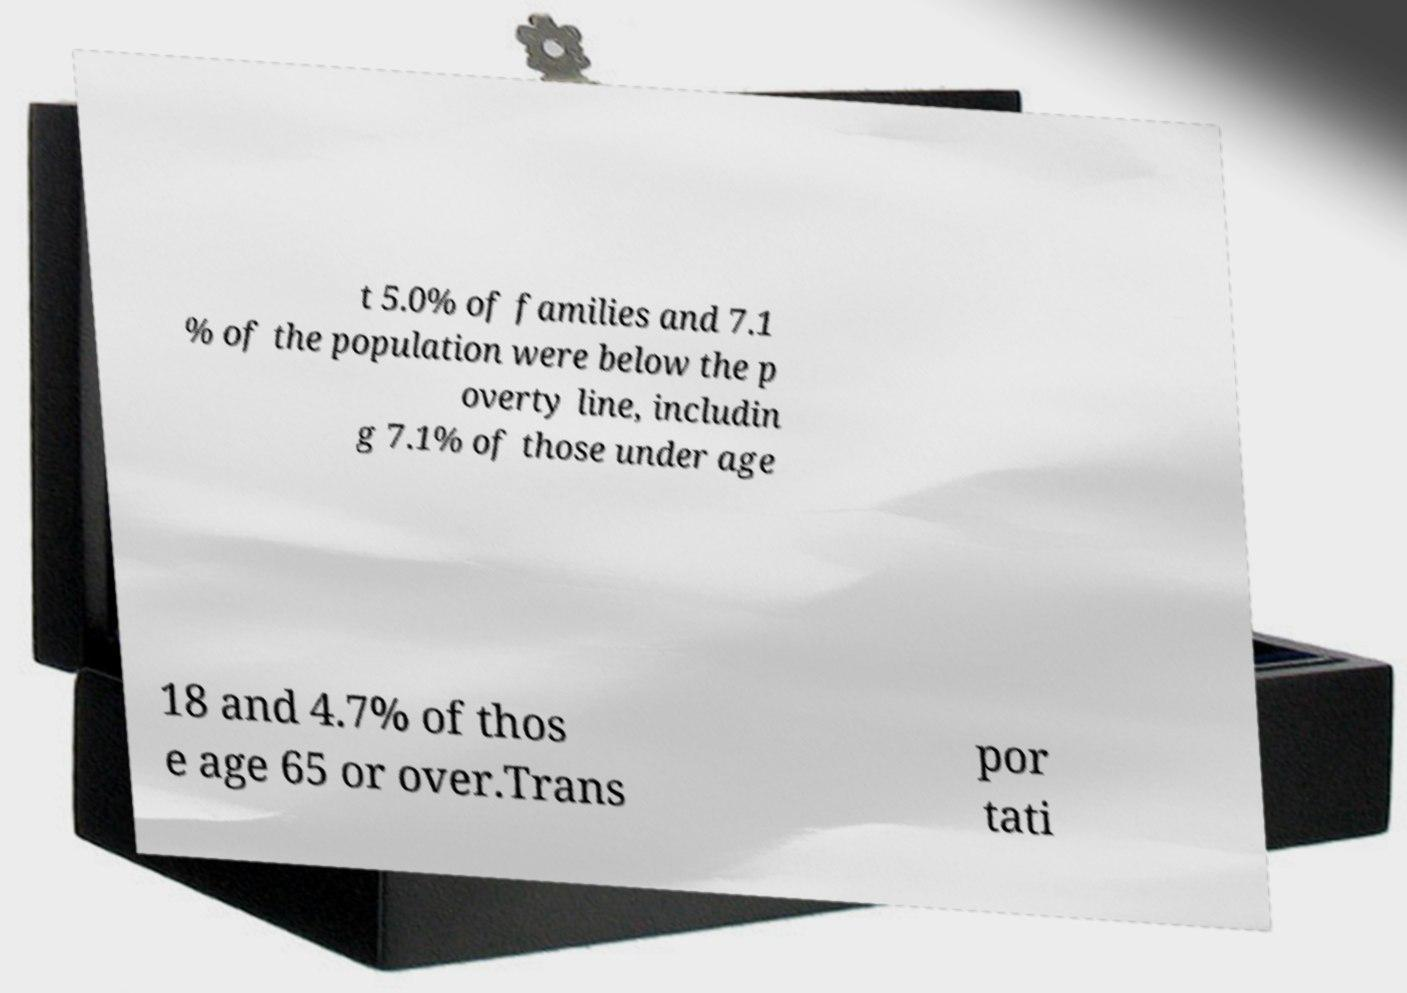Could you extract and type out the text from this image? t 5.0% of families and 7.1 % of the population were below the p overty line, includin g 7.1% of those under age 18 and 4.7% of thos e age 65 or over.Trans por tati 